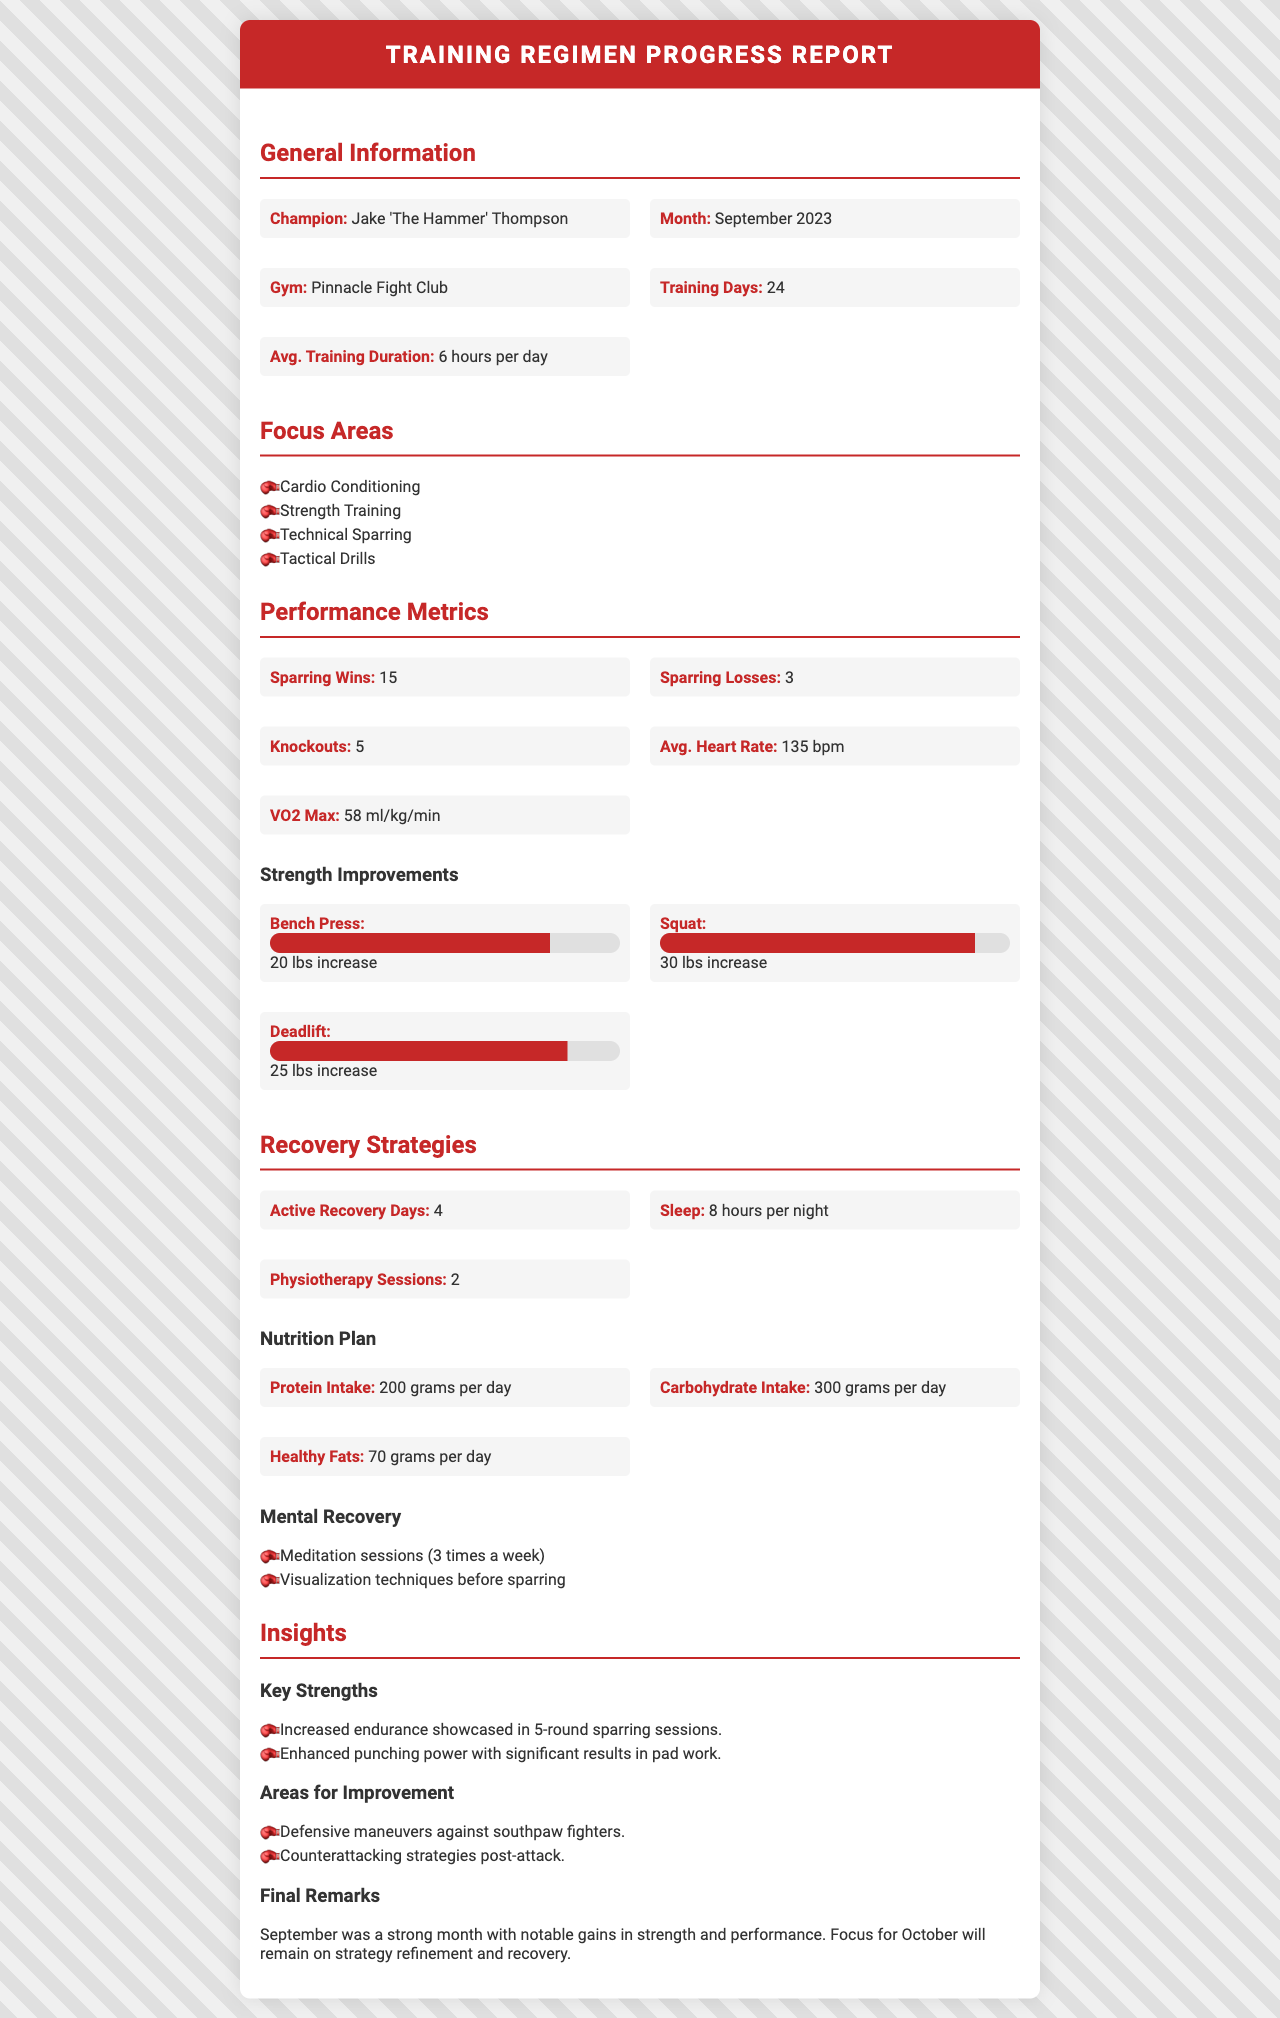What is the champion's name? The champion's name is mentioned in the General Information section of the document.
Answer: Jake 'The Hammer' Thompson How many training days were recorded in September? The document specifies the number of training days in the General Information section.
Answer: 24 What was the average training duration per day? The average training duration is provided in the General Information section and reflects the time spent each day.
Answer: 6 hours per day What was the VO2 Max recorded for the month? The VO2 Max is listed under the Performance Metrics section, indicating aerobic capacity.
Answer: 58 ml/kg/min What was the increase in the squat strength? The increase in squat strength is detailed in the Strength Improvements section of the document.
Answer: 30 lbs increase How many active recovery days were taken during September? The number of active recovery days is found in the Recovery Strategies section.
Answer: 4 How many times a week were meditation sessions conducted? The frequency of meditation sessions is stated under the Mental Recovery section.
Answer: 3 times a week What were the key strengths identified? The key strengths are summarized in the Insights section, reflecting the champion's performance.
Answer: Increased endurance, enhanced punching power What specific area needs improvement regarding opponent type? The areas for improvement section identifies specific strategies needing focus.
Answer: Defensive maneuvers against southpaw fighters What is the focus for the next month according to final remarks? The final remarks of the document indicate future training focus.
Answer: Strategy refinement and recovery 